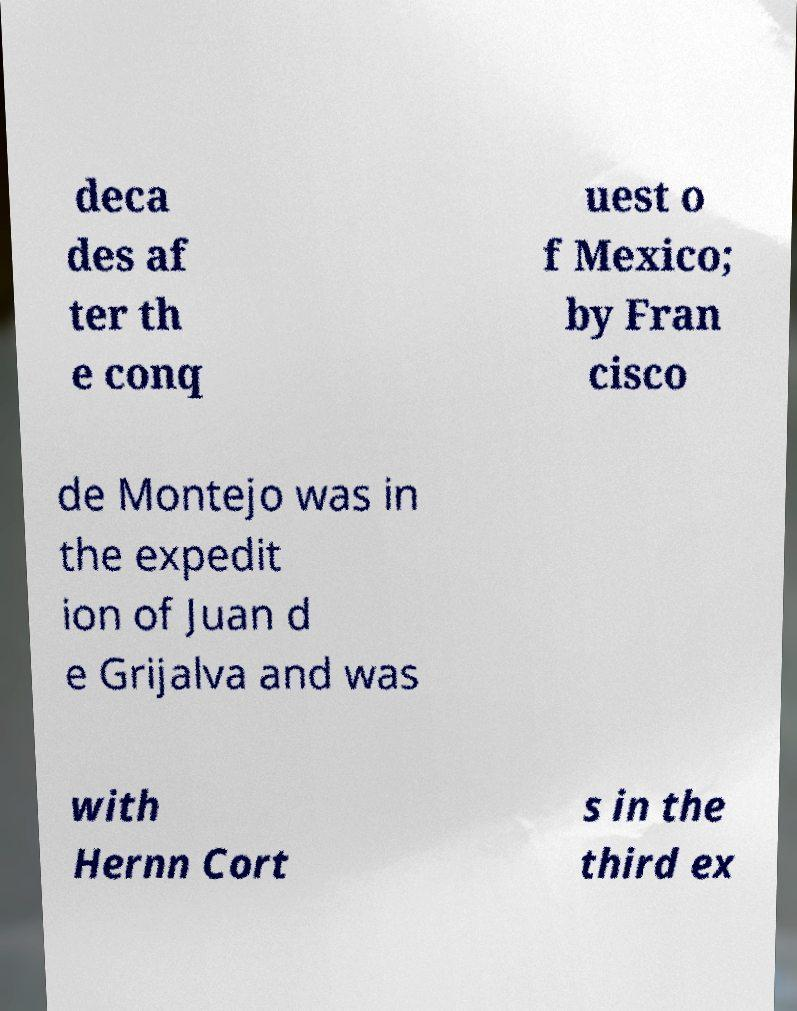Please identify and transcribe the text found in this image. deca des af ter th e conq uest o f Mexico; by Fran cisco de Montejo was in the expedit ion of Juan d e Grijalva and was with Hernn Cort s in the third ex 